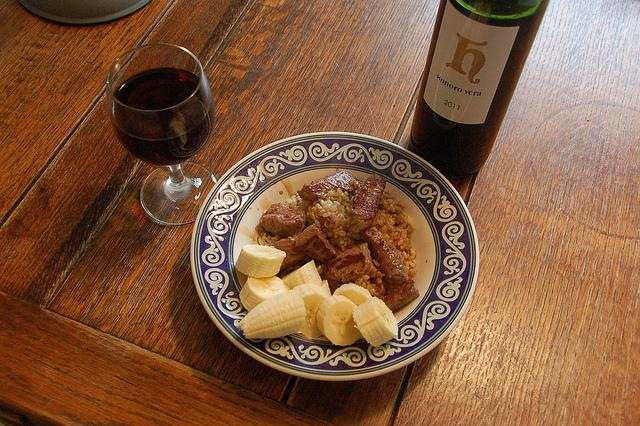Which item contains a lot of potassium? Please explain your reasoning. banana. The fruit is a good source of potassium. 